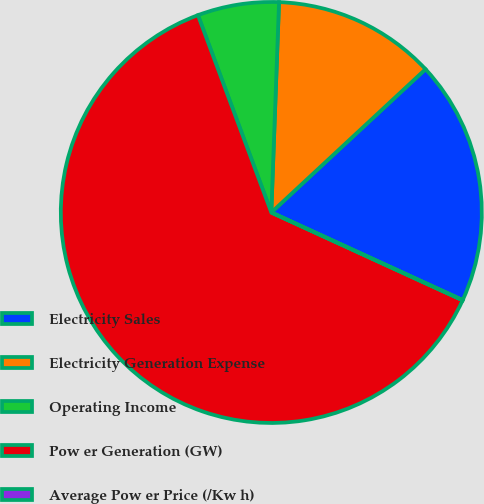<chart> <loc_0><loc_0><loc_500><loc_500><pie_chart><fcel>Electricity Sales<fcel>Electricity Generation Expense<fcel>Operating Income<fcel>Pow er Generation (GW)<fcel>Average Pow er Price (/Kw h)<nl><fcel>18.75%<fcel>12.5%<fcel>6.25%<fcel>62.49%<fcel>0.01%<nl></chart> 